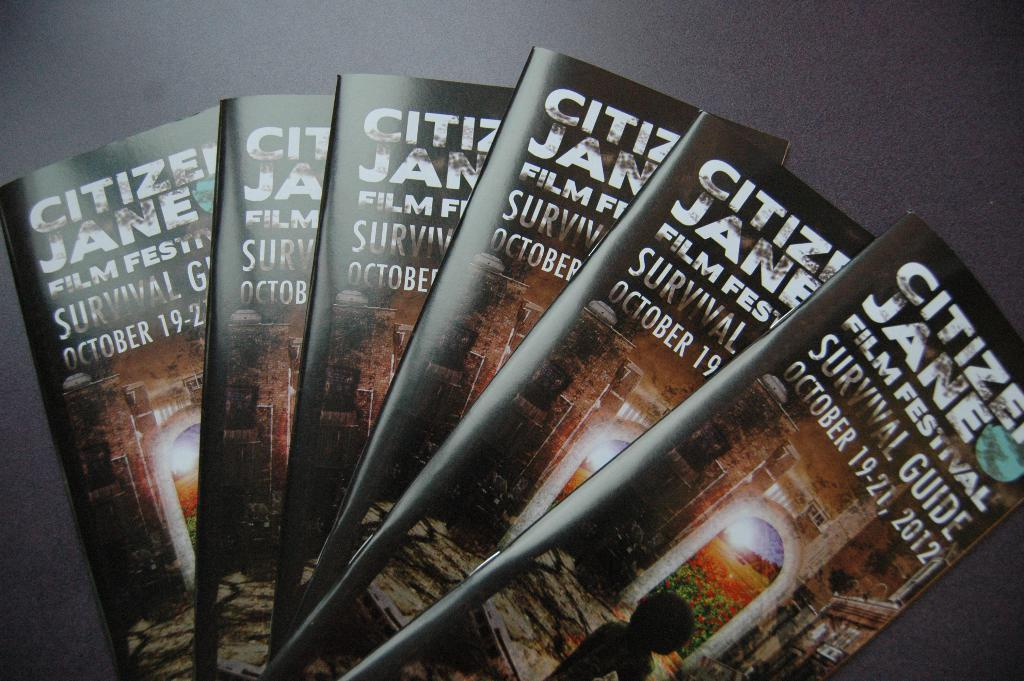<image>
Give a short and clear explanation of the subsequent image. A stack of Citizen Jane film festival survivor guide pamphlets. 